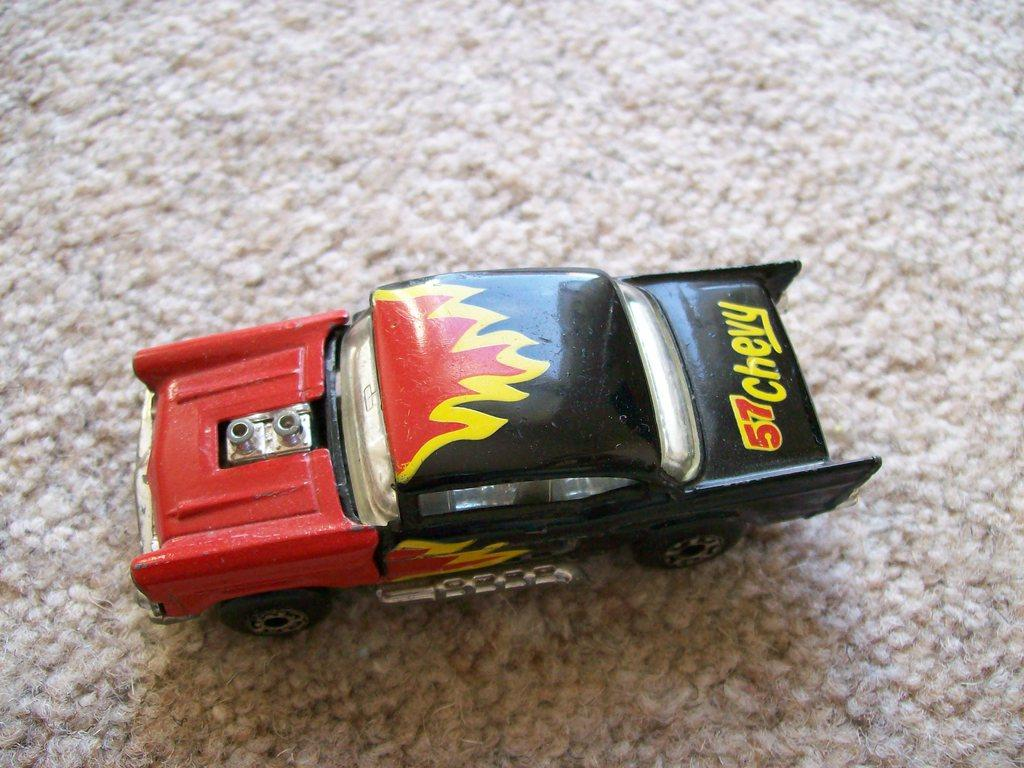What is the main object in the image? There is a toy car in the image. What colors can be seen on the toy car? The toy car has red and black colors. What is at the bottom of the image? There appears to be a mat at the bottom of the image. What type of wall can be seen in the image? There is no wall present in the image; it features a toy car on a mat. What territory is being claimed by the toy car in the image? The toy car is not claiming any territory in the image; it is simply a toy on a mat. 